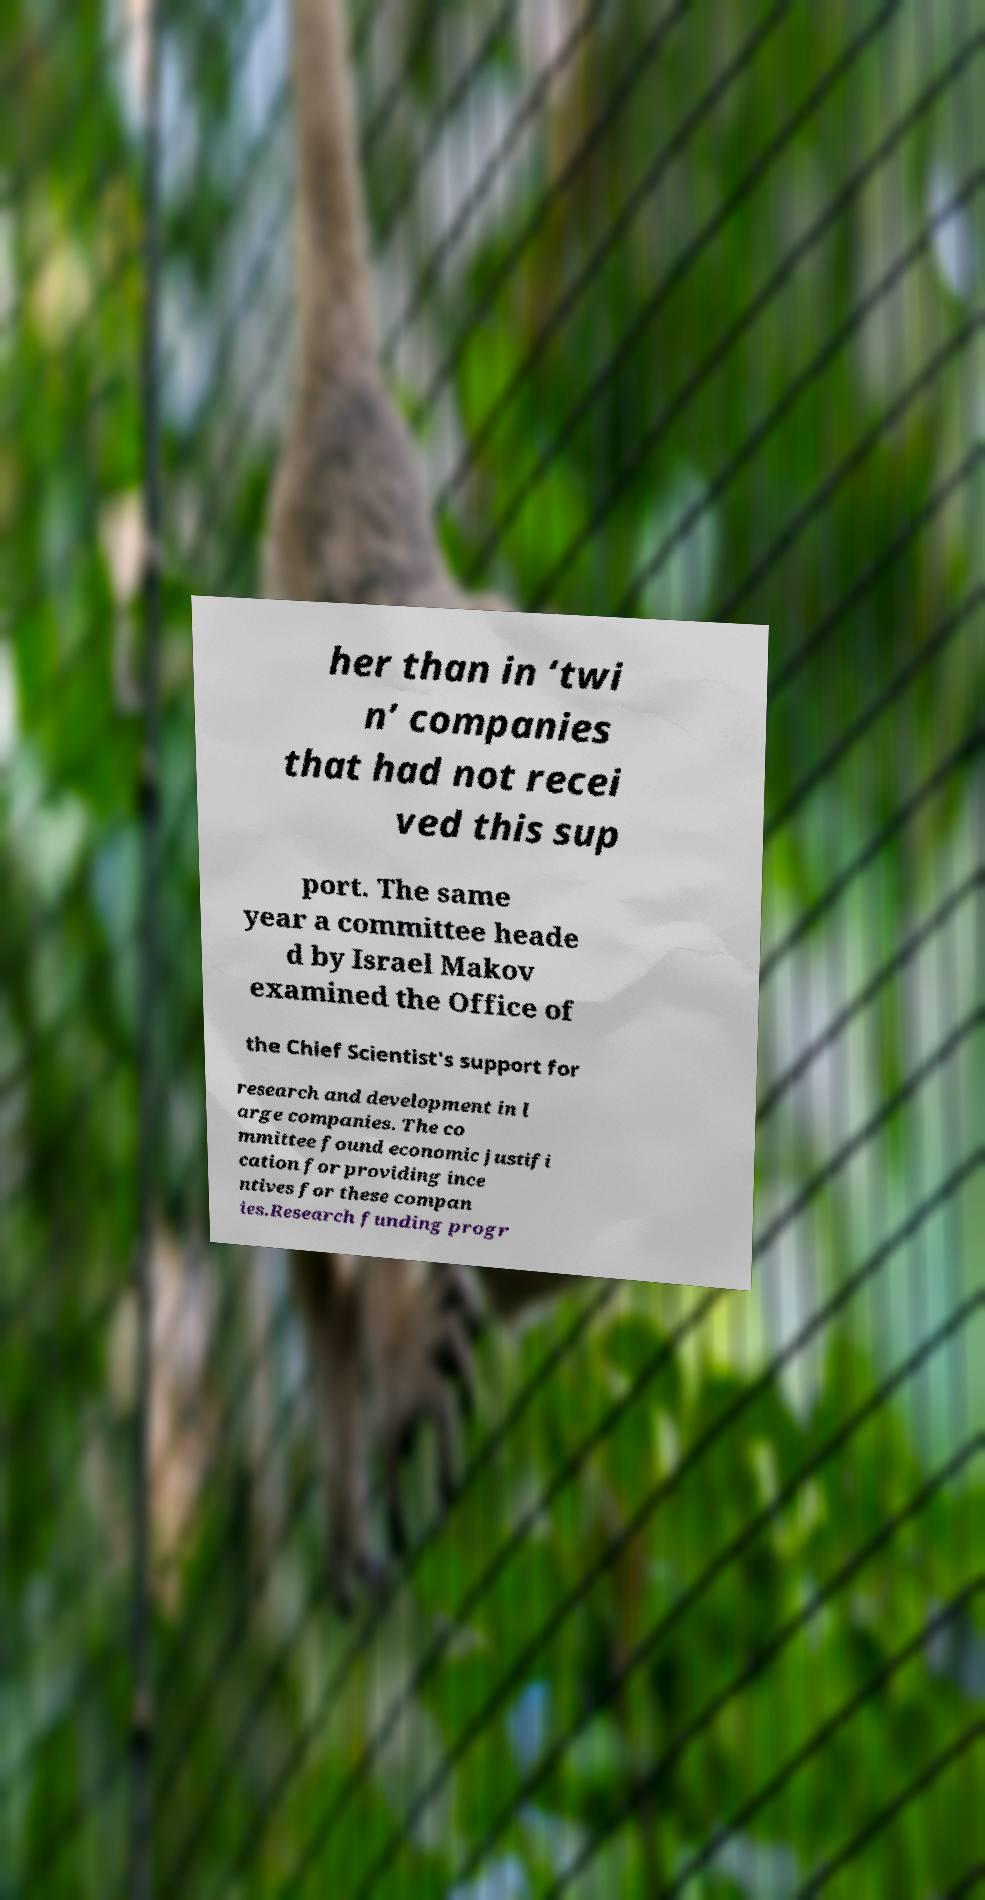Please identify and transcribe the text found in this image. her than in ‘twi n’ companies that had not recei ved this sup port. The same year a committee heade d by Israel Makov examined the Office of the Chief Scientist's support for research and development in l arge companies. The co mmittee found economic justifi cation for providing ince ntives for these compan ies.Research funding progr 